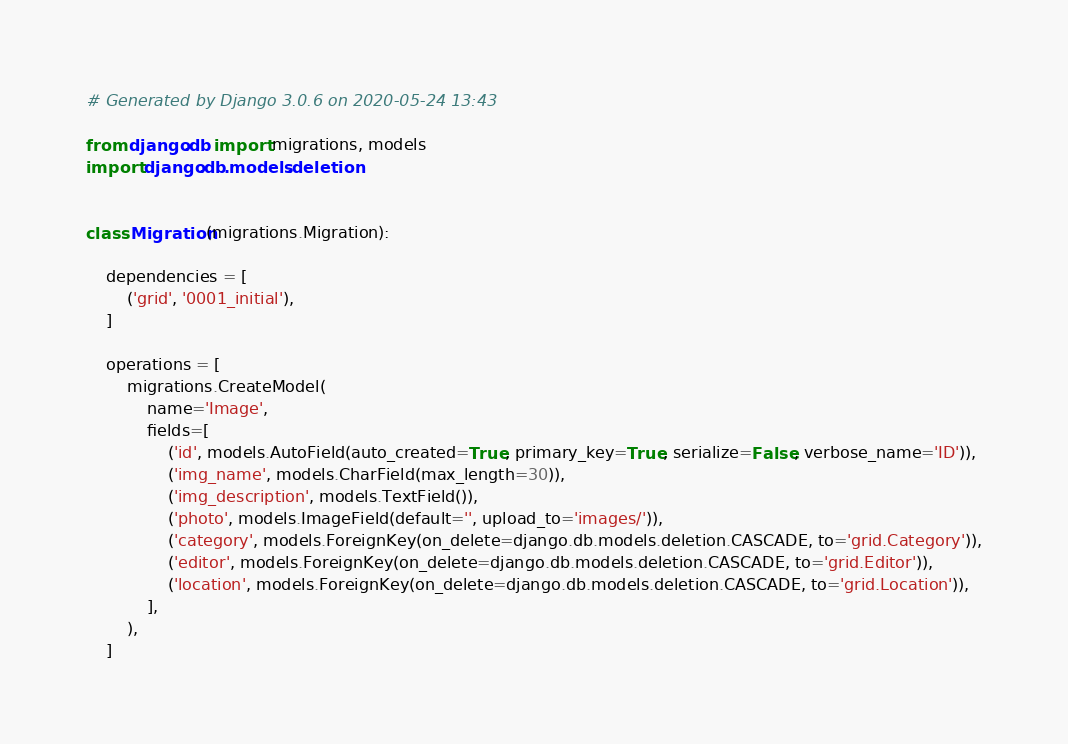<code> <loc_0><loc_0><loc_500><loc_500><_Python_># Generated by Django 3.0.6 on 2020-05-24 13:43

from django.db import migrations, models
import django.db.models.deletion


class Migration(migrations.Migration):

    dependencies = [
        ('grid', '0001_initial'),
    ]

    operations = [
        migrations.CreateModel(
            name='Image',
            fields=[
                ('id', models.AutoField(auto_created=True, primary_key=True, serialize=False, verbose_name='ID')),
                ('img_name', models.CharField(max_length=30)),
                ('img_description', models.TextField()),
                ('photo', models.ImageField(default='', upload_to='images/')),
                ('category', models.ForeignKey(on_delete=django.db.models.deletion.CASCADE, to='grid.Category')),
                ('editor', models.ForeignKey(on_delete=django.db.models.deletion.CASCADE, to='grid.Editor')),
                ('location', models.ForeignKey(on_delete=django.db.models.deletion.CASCADE, to='grid.Location')),
            ],
        ),
    ]
</code> 